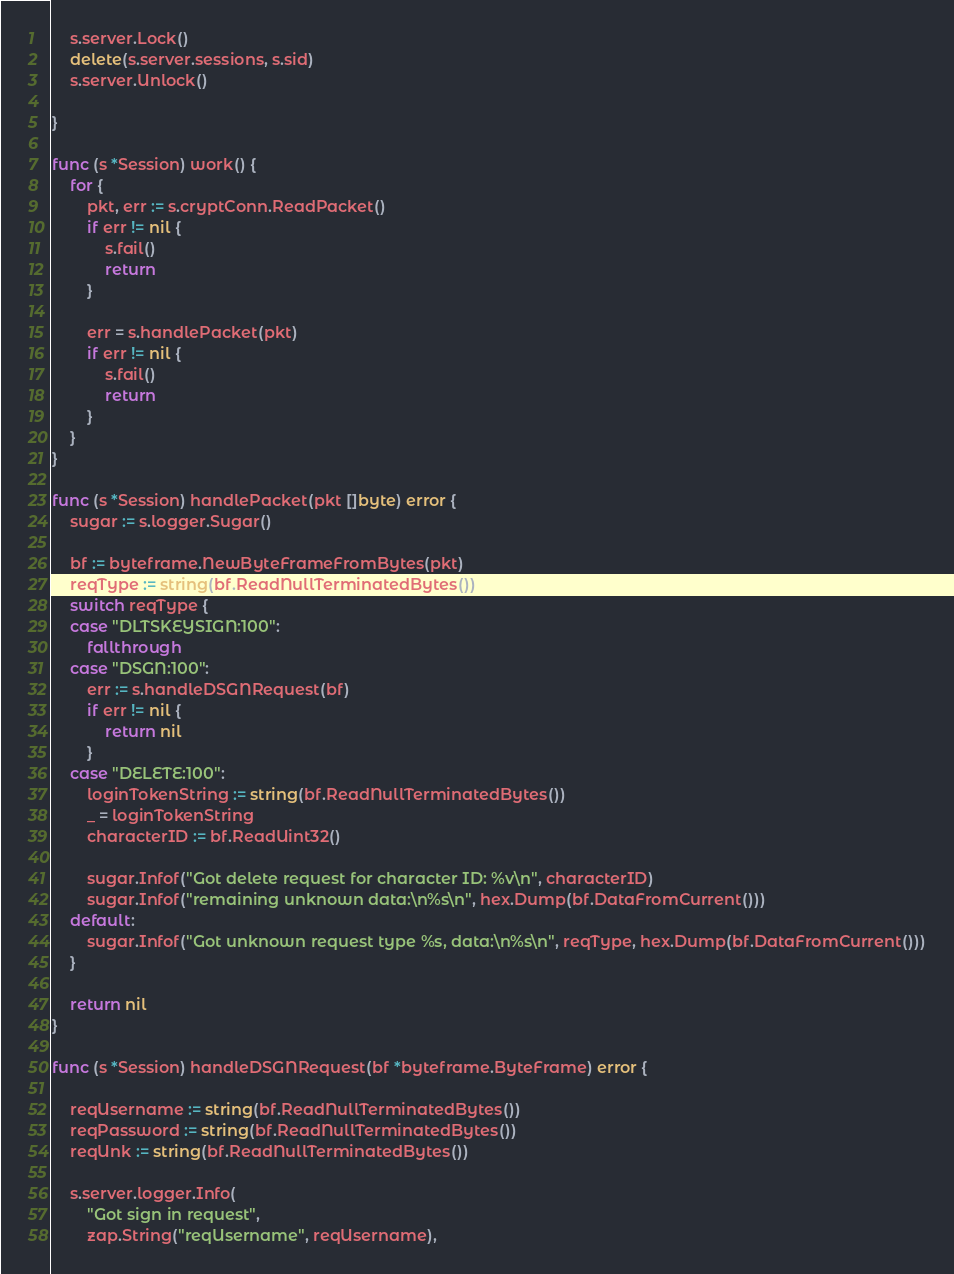<code> <loc_0><loc_0><loc_500><loc_500><_Go_>	s.server.Lock()
	delete(s.server.sessions, s.sid)
	s.server.Unlock()

}

func (s *Session) work() {
	for {
		pkt, err := s.cryptConn.ReadPacket()
		if err != nil {
			s.fail()
			return
		}

		err = s.handlePacket(pkt)
		if err != nil {
			s.fail()
			return
		}
	}
}

func (s *Session) handlePacket(pkt []byte) error {
	sugar := s.logger.Sugar()

	bf := byteframe.NewByteFrameFromBytes(pkt)
	reqType := string(bf.ReadNullTerminatedBytes())
	switch reqType {
	case "DLTSKEYSIGN:100":
		fallthrough
	case "DSGN:100":
		err := s.handleDSGNRequest(bf)
		if err != nil {
			return nil
		}
	case "DELETE:100":
		loginTokenString := string(bf.ReadNullTerminatedBytes())
		_ = loginTokenString
		characterID := bf.ReadUint32()

		sugar.Infof("Got delete request for character ID: %v\n", characterID)
		sugar.Infof("remaining unknown data:\n%s\n", hex.Dump(bf.DataFromCurrent()))
	default:
		sugar.Infof("Got unknown request type %s, data:\n%s\n", reqType, hex.Dump(bf.DataFromCurrent()))
	}

	return nil
}

func (s *Session) handleDSGNRequest(bf *byteframe.ByteFrame) error {

	reqUsername := string(bf.ReadNullTerminatedBytes())
	reqPassword := string(bf.ReadNullTerminatedBytes())
	reqUnk := string(bf.ReadNullTerminatedBytes())

	s.server.logger.Info(
		"Got sign in request",
		zap.String("reqUsername", reqUsername),</code> 